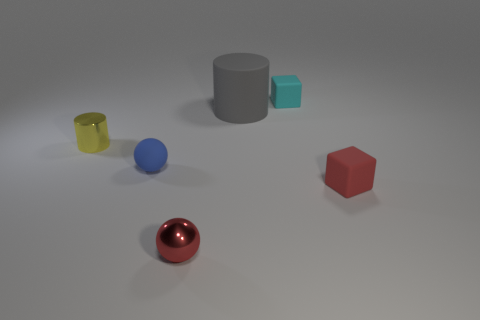Add 4 small cylinders. How many objects exist? 10 Add 3 small cyan matte cubes. How many small cyan matte cubes are left? 4 Add 6 yellow matte spheres. How many yellow matte spheres exist? 6 Subtract 0 yellow cubes. How many objects are left? 6 Subtract all metallic cylinders. Subtract all big gray rubber objects. How many objects are left? 4 